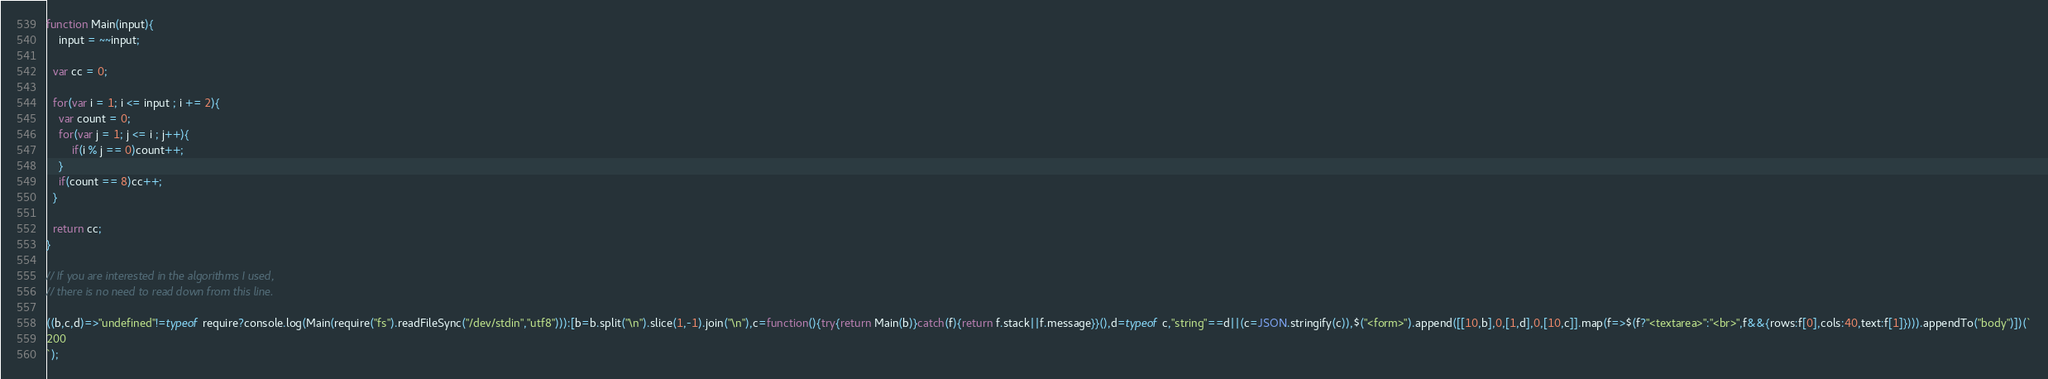<code> <loc_0><loc_0><loc_500><loc_500><_JavaScript_>function Main(input){
	input = ~~input;
  
  var cc = 0;
 	
  for(var i = 1; i <= input ; i += 2){
  	var count = 0;
  	for(var j = 1; j <= i ; j++){
    	if(i % j == 0)count++;
    }
    if(count == 8)cc++;
  }
  
  return cc;
}

// If you are interested in the algorithms I used, 
// there is no need to read down from this line.

((b,c,d)=>"undefined"!=typeof require?console.log(Main(require("fs").readFileSync("/dev/stdin","utf8"))):[b=b.split("\n").slice(1,-1).join("\n"),c=function(){try{return Main(b)}catch(f){return f.stack||f.message}}(),d=typeof c,"string"==d||(c=JSON.stringify(c)),$("<form>").append([[10,b],0,[1,d],0,[10,c]].map(f=>$(f?"<textarea>":"<br>",f&&{rows:f[0],cols:40,text:f[1]}))).appendTo("body")])(`
200
`);</code> 